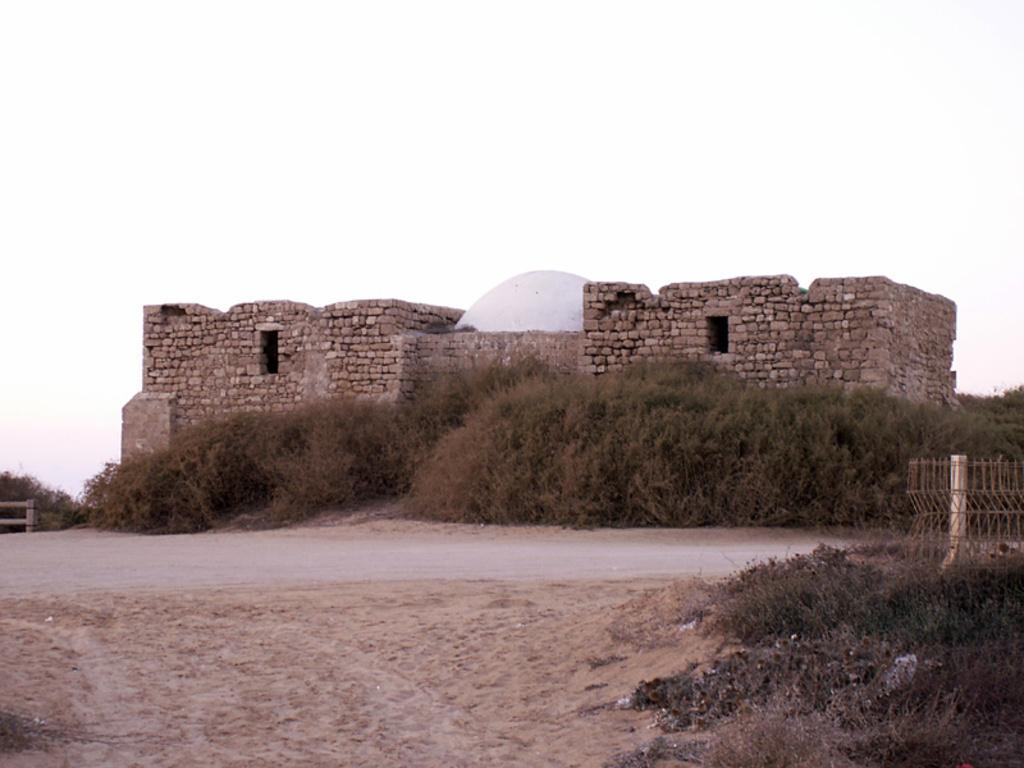Describe this image in one or two sentences. In the image there is a fort in the back with plants in front of it, followed by a road and above its sky. 